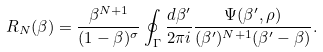<formula> <loc_0><loc_0><loc_500><loc_500>R _ { N } ( \beta ) = { \frac { \beta ^ { N + 1 } } { ( 1 - \beta ) ^ { \sigma } } } \oint _ { \Gamma } { \frac { d \beta ^ { \prime } } { 2 \pi i } } { \frac { \Psi ( \beta ^ { \prime } , \rho ) } { ( \beta ^ { \prime } ) ^ { N + 1 } ( \beta ^ { \prime } - \beta ) } } .</formula> 